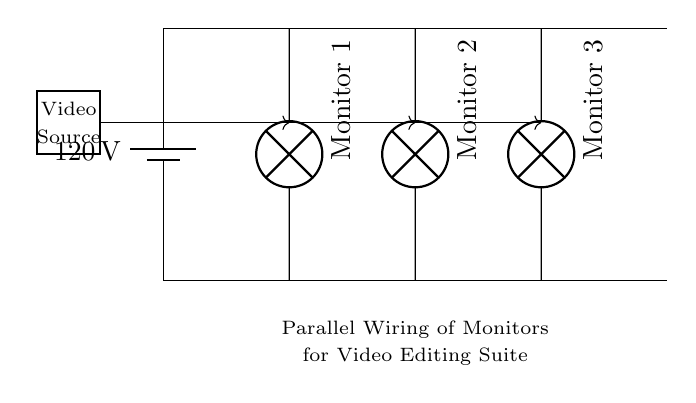What is the voltage of the power supply? The circuit diagram labels the power supply as having a voltage of 120 volts. This is indicated next to the battery symbol.
Answer: 120 volts How many monitors are connected in parallel? The diagram has three monitor symbols connected in parallel, each labeled as Monitor 1, Monitor 2, and Monitor 3. This indicates there are three monitors.
Answer: Three What is the source of the video signal? The video signal source is represented by a rectangle labeled "Video Source" on the left side of the diagram, indicating the origin of the footage being analyzed.
Answer: Video Source What do the arrows represent in the circuit? The arrows in the circuit indicate the flow of the video signal, showing how it travels from the video source to each monitor.
Answer: Flow of video signal Which component is in the center of the circuit? The central component in the circuit is the main power line that runs horizontally across the diagram and connects to the monitors.
Answer: Main power line What type of wiring configuration is shown in the diagram? The diagram illustrates a parallel wiring configuration, as indicated by the arrangement of the monitors connected to the same power supply and video source.
Answer: Parallel wiring 